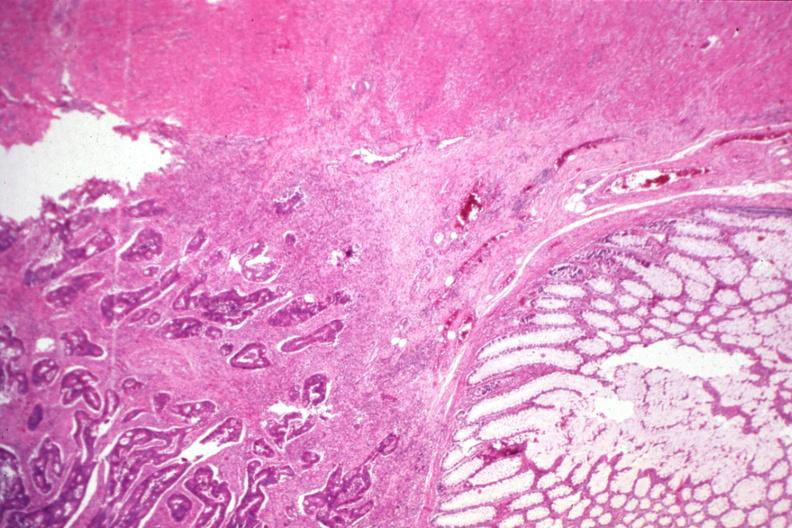what is present?
Answer the question using a single word or phrase. Gastrointestinal 